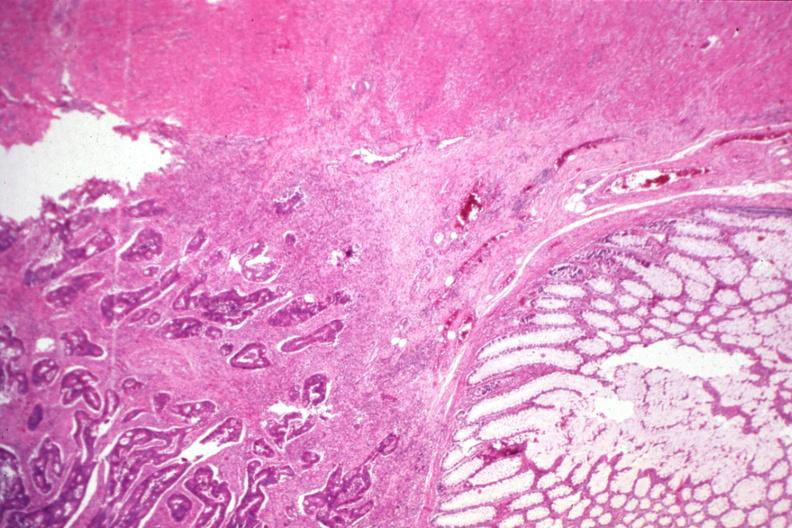what is present?
Answer the question using a single word or phrase. Gastrointestinal 